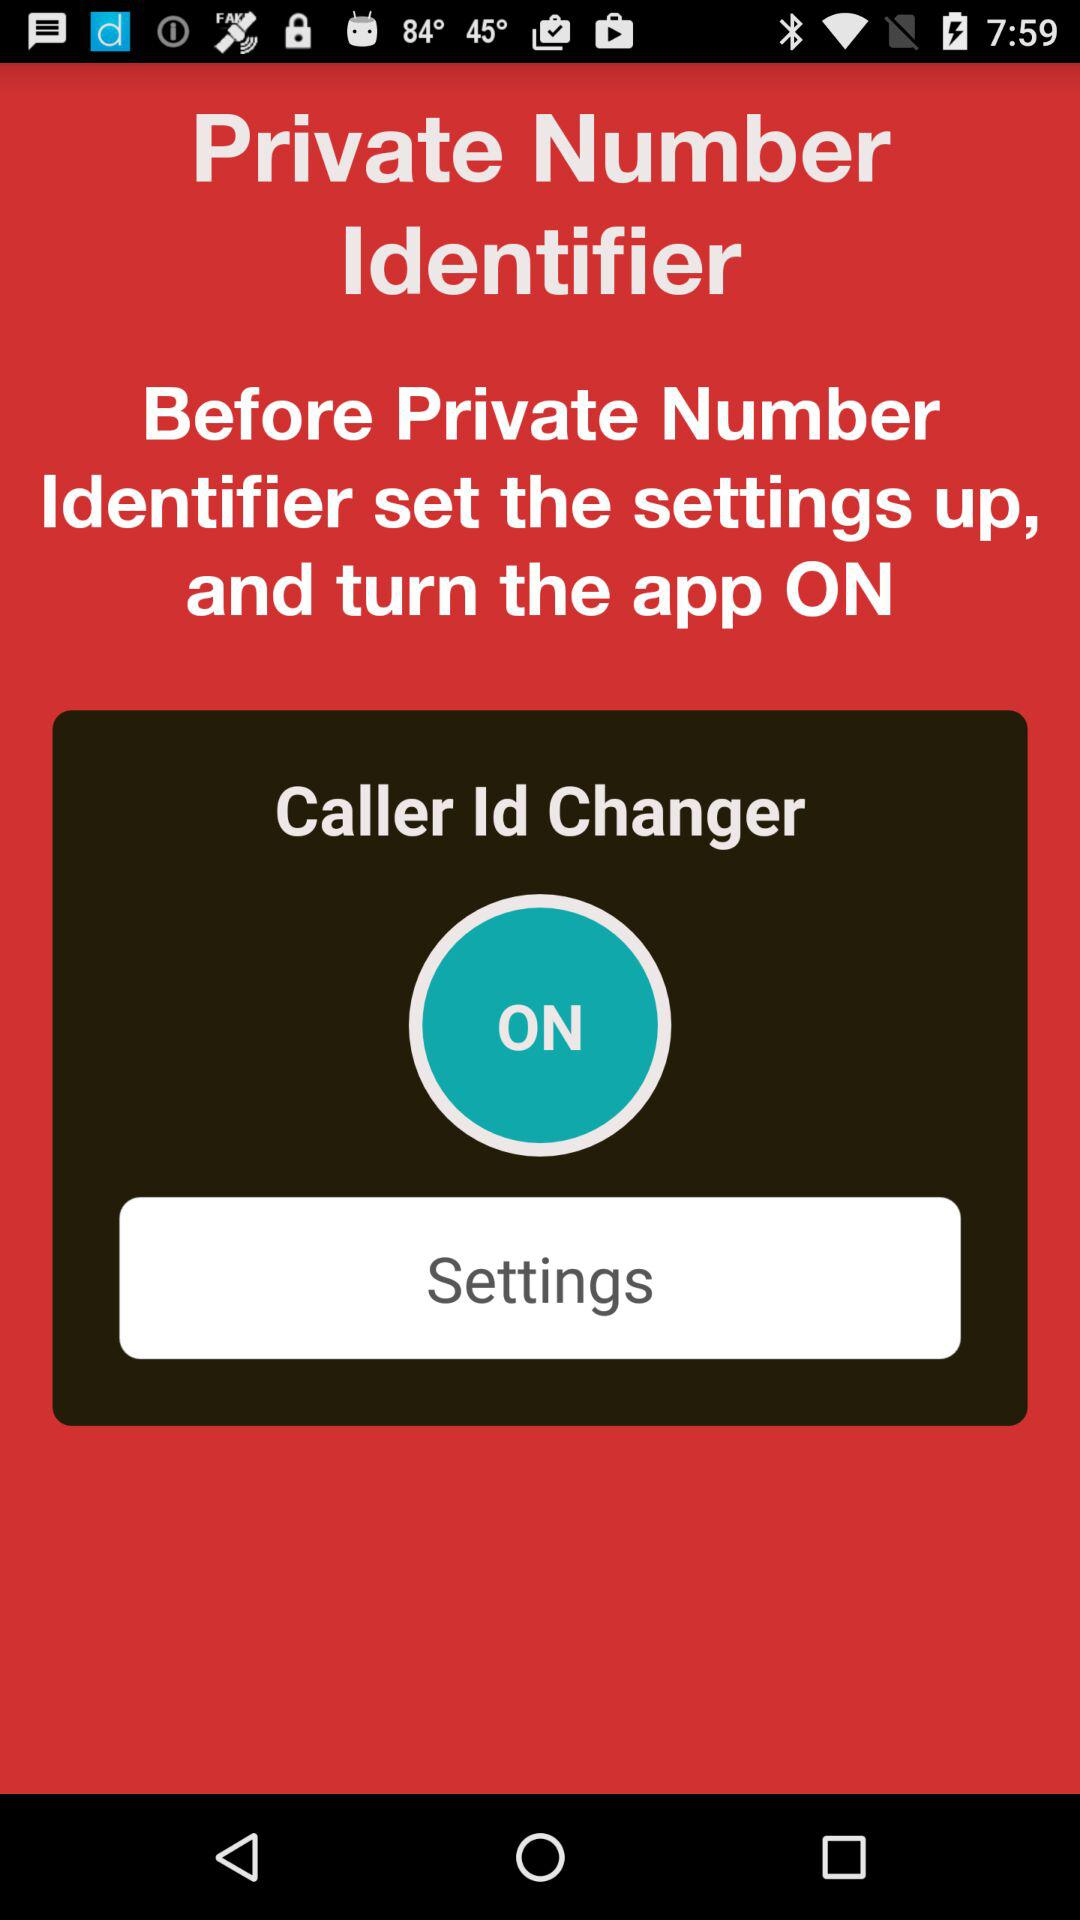What is the application name? The application name is "Private Number Identifier". 